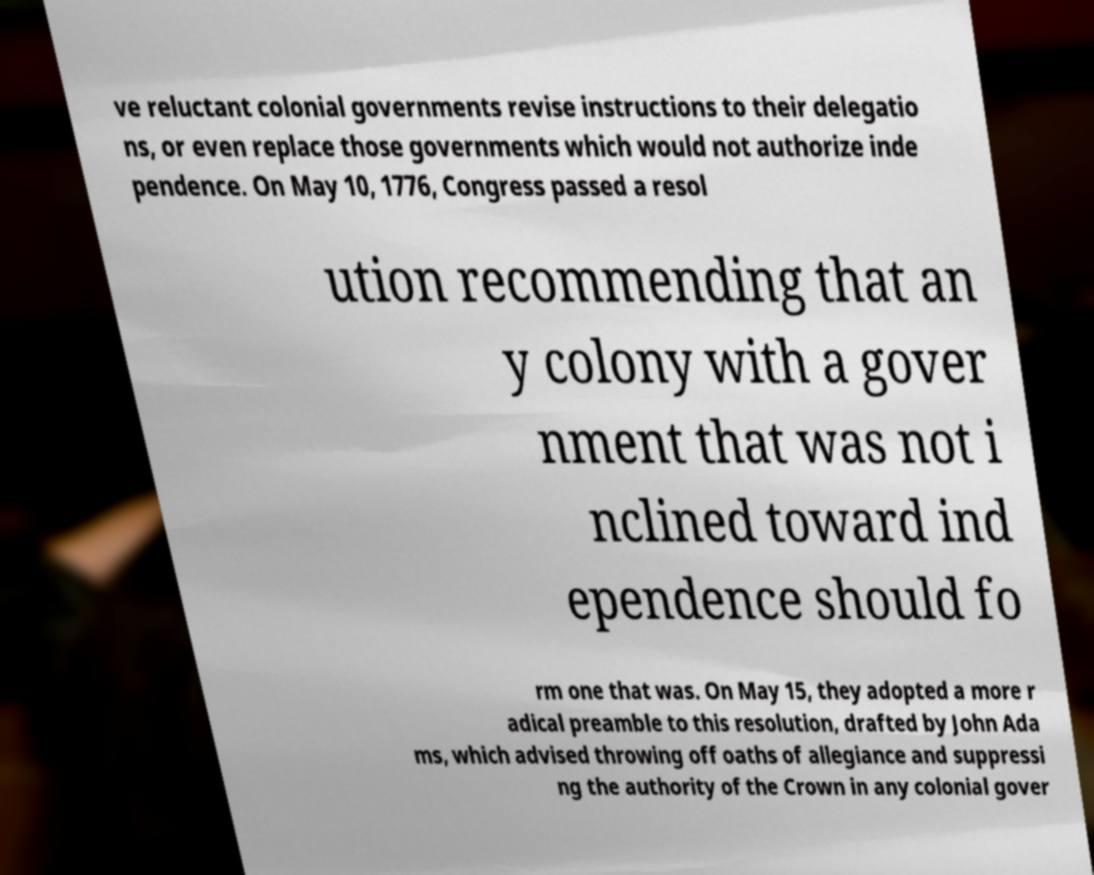Could you assist in decoding the text presented in this image and type it out clearly? ve reluctant colonial governments revise instructions to their delegatio ns, or even replace those governments which would not authorize inde pendence. On May 10, 1776, Congress passed a resol ution recommending that an y colony with a gover nment that was not i nclined toward ind ependence should fo rm one that was. On May 15, they adopted a more r adical preamble to this resolution, drafted by John Ada ms, which advised throwing off oaths of allegiance and suppressi ng the authority of the Crown in any colonial gover 